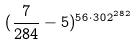<formula> <loc_0><loc_0><loc_500><loc_500>( \frac { 7 } { 2 8 4 } - 5 ) ^ { 5 6 \cdot 3 0 2 ^ { 2 8 2 } }</formula> 